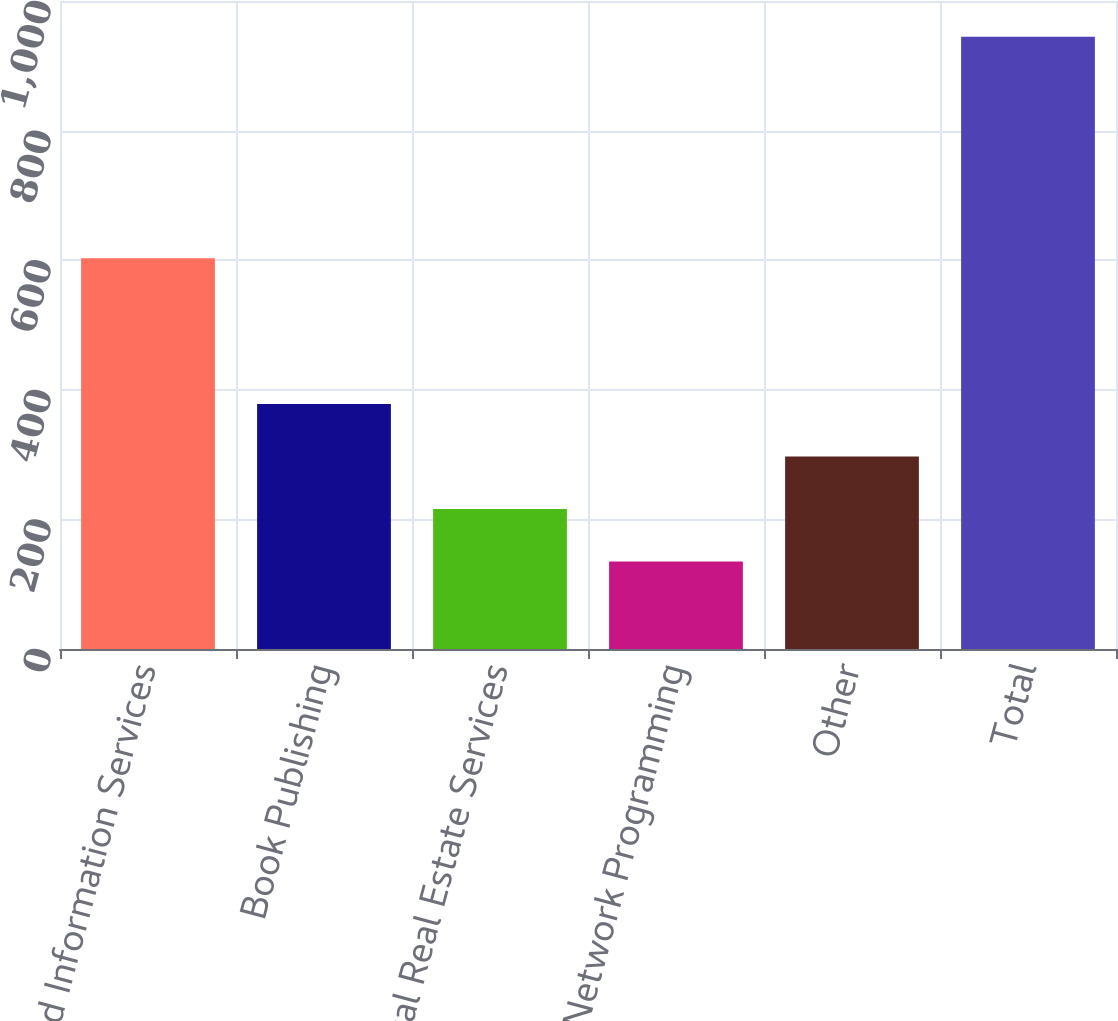Convert chart. <chart><loc_0><loc_0><loc_500><loc_500><bar_chart><fcel>News and Information Services<fcel>Book Publishing<fcel>Digital Real Estate Services<fcel>Cable Network Programming<fcel>Other<fcel>Total<nl><fcel>603<fcel>378<fcel>216<fcel>135<fcel>297<fcel>945<nl></chart> 